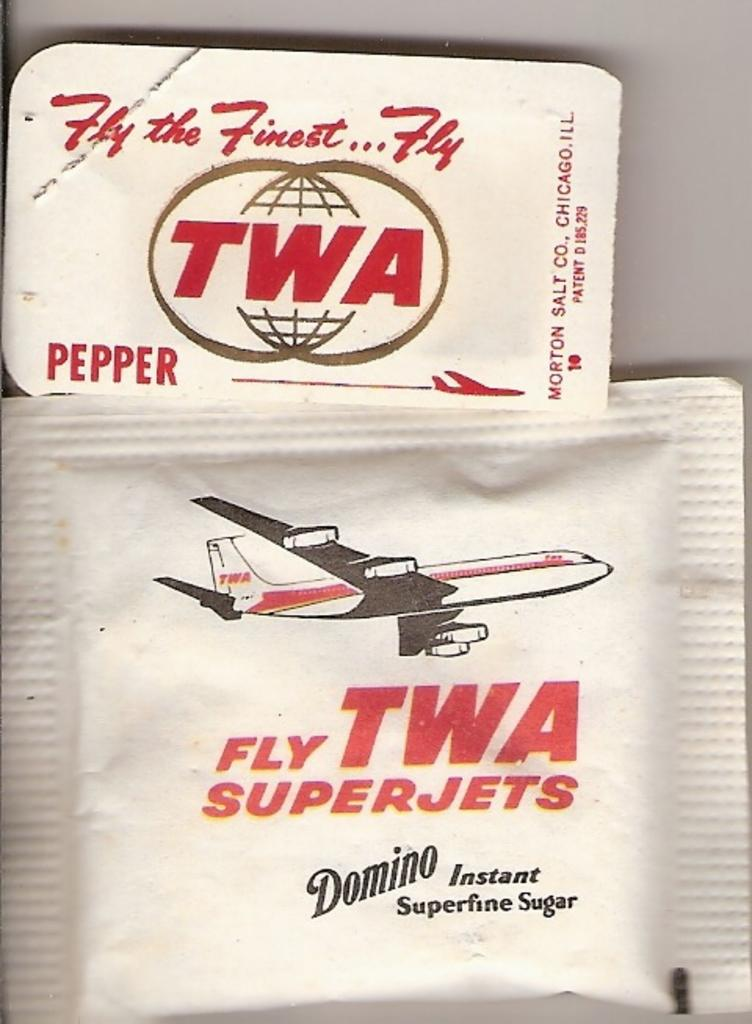<image>
Give a short and clear explanation of the subsequent image. Pepper and sugar packets from TWA airlines sit against a white background 